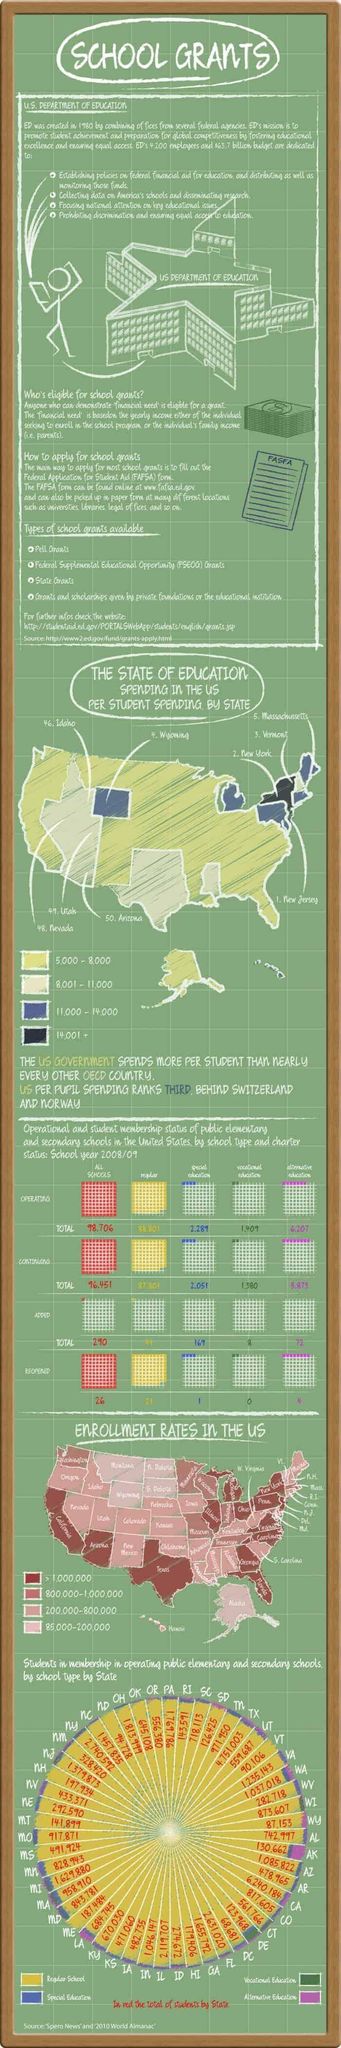Highlight a few significant elements in this photo. Four types of school grants have been listed. 